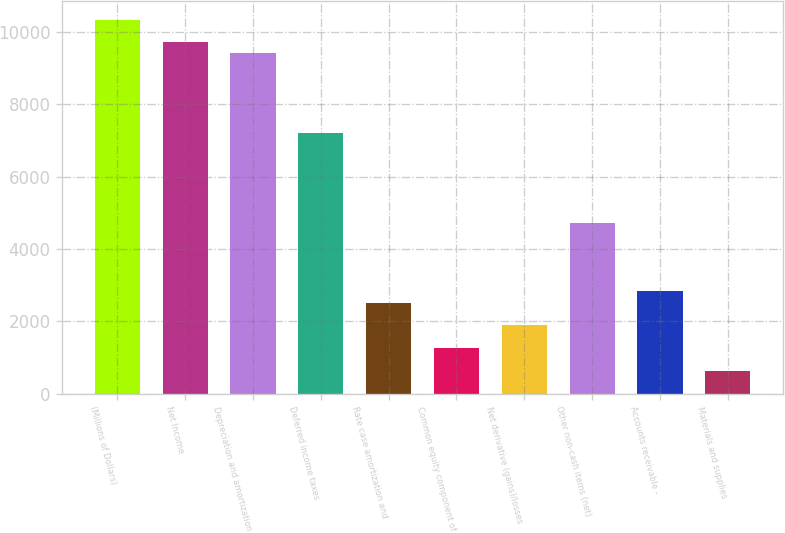Convert chart. <chart><loc_0><loc_0><loc_500><loc_500><bar_chart><fcel>(Millions of Dollars)<fcel>Net Income<fcel>Depreciation and amortization<fcel>Deferred income taxes<fcel>Rate case amortization and<fcel>Common equity component of<fcel>Net derivative (gains)/losses<fcel>Other non-cash items (net)<fcel>Accounts receivable -<fcel>Materials and supplies<nl><fcel>10342.9<fcel>9716.3<fcel>9403<fcel>7209.9<fcel>2510.4<fcel>1257.2<fcel>1883.8<fcel>4703.5<fcel>2823.7<fcel>630.6<nl></chart> 